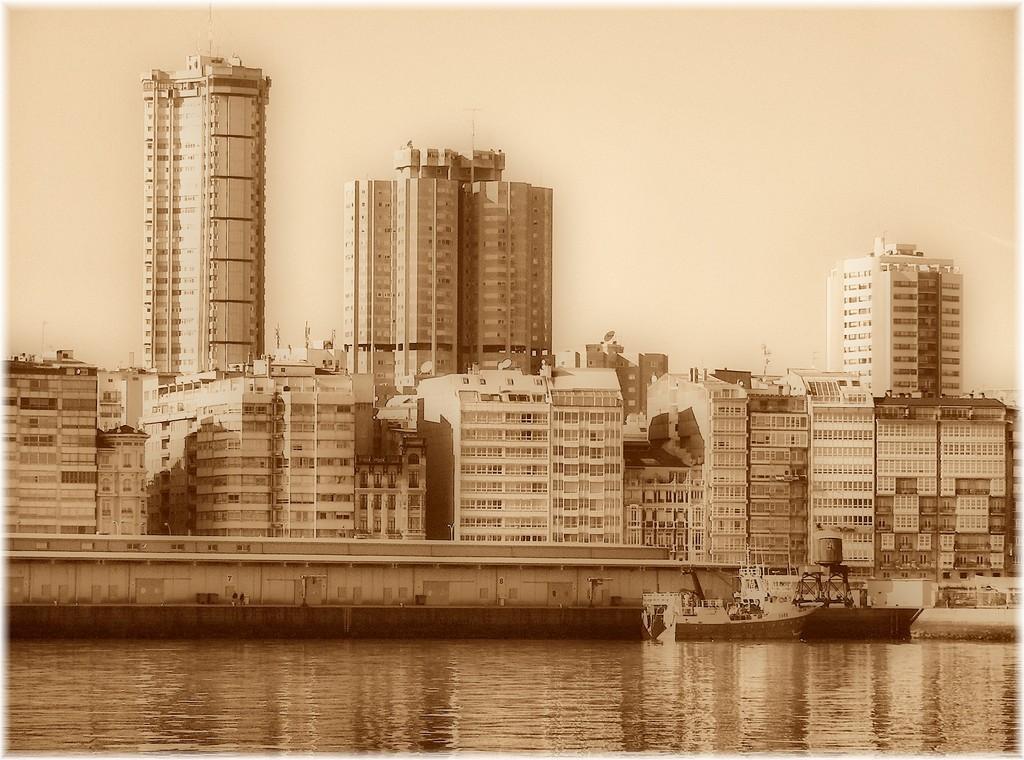Can you describe this image briefly? In this image we can see ship on the water, buildings, antennas and sky. 